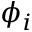<formula> <loc_0><loc_0><loc_500><loc_500>\phi _ { i }</formula> 